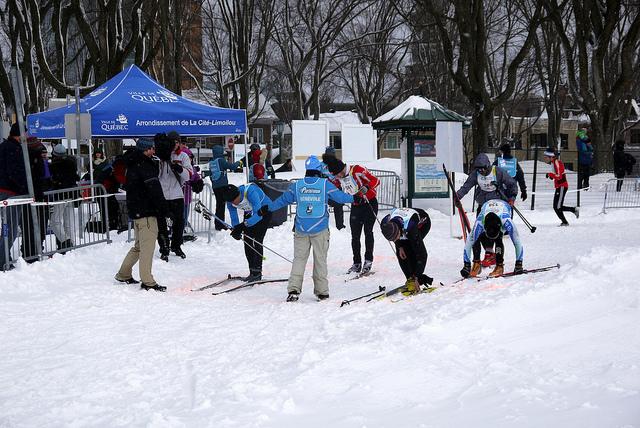What sport are they preparing for?
Short answer required. Skiing. Is the ground covered with snow?
Quick response, please. Yes. Are they friends?
Keep it brief. Yes. Are they eating chicken?
Answer briefly. No. 